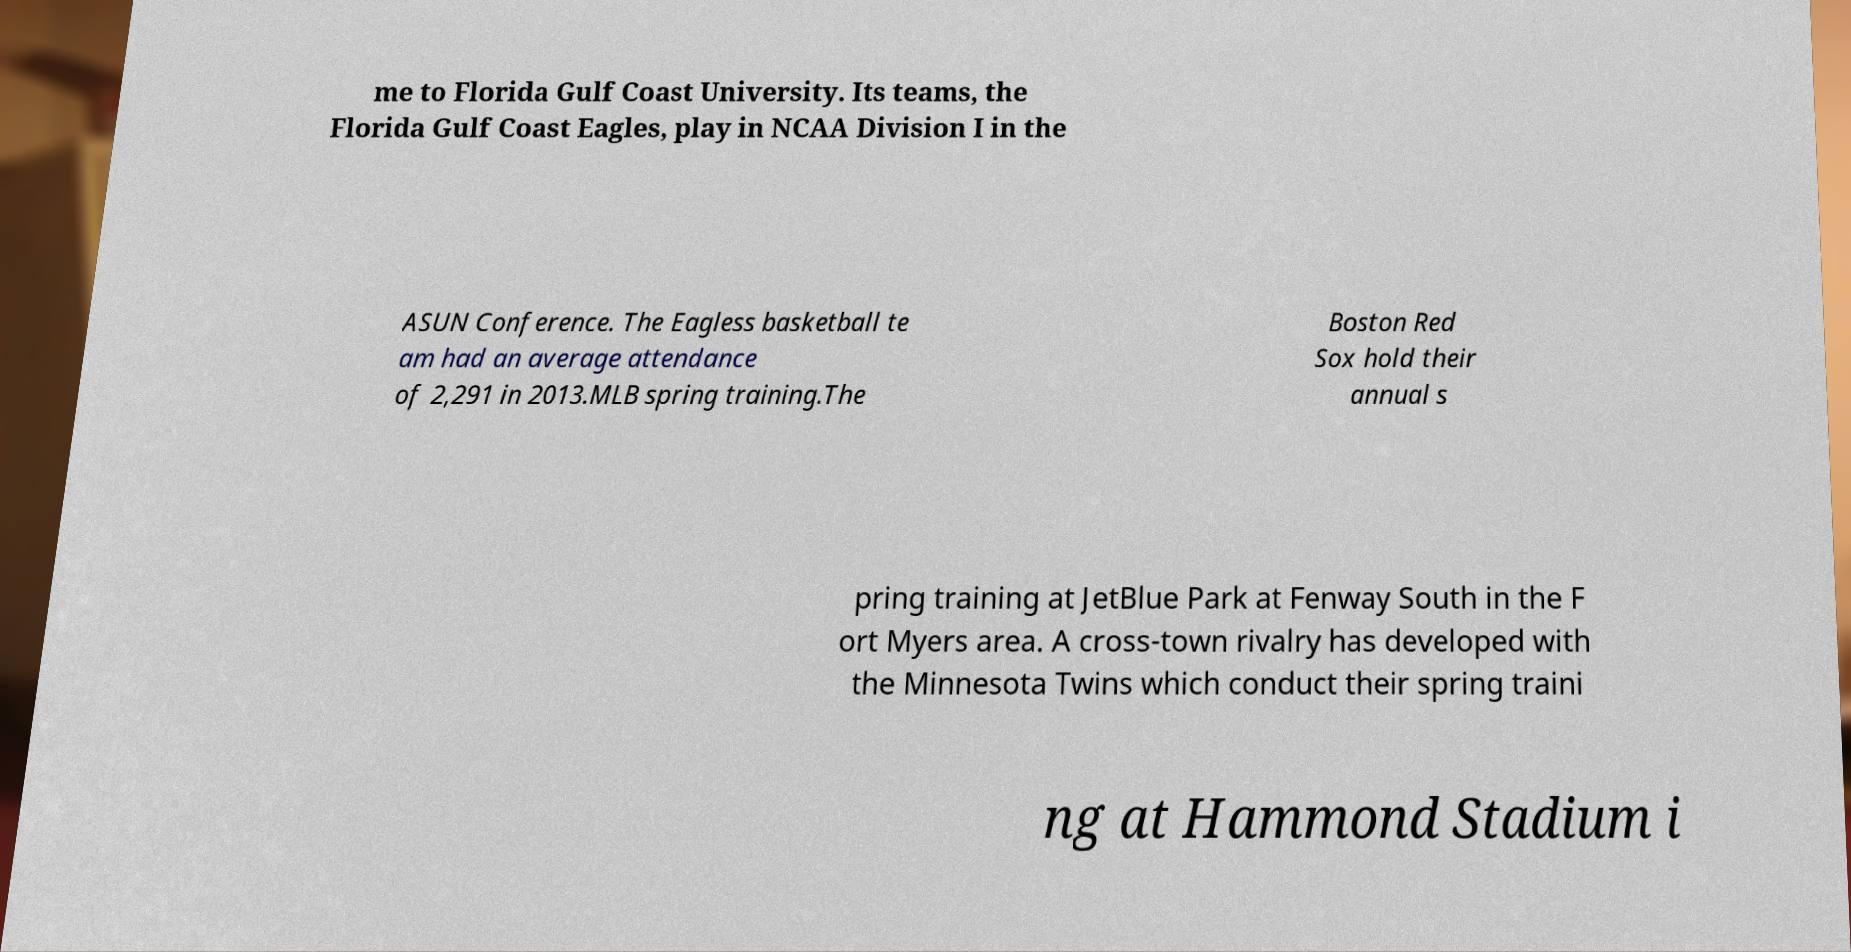I need the written content from this picture converted into text. Can you do that? me to Florida Gulf Coast University. Its teams, the Florida Gulf Coast Eagles, play in NCAA Division I in the ASUN Conference. The Eagless basketball te am had an average attendance of 2,291 in 2013.MLB spring training.The Boston Red Sox hold their annual s pring training at JetBlue Park at Fenway South in the F ort Myers area. A cross-town rivalry has developed with the Minnesota Twins which conduct their spring traini ng at Hammond Stadium i 